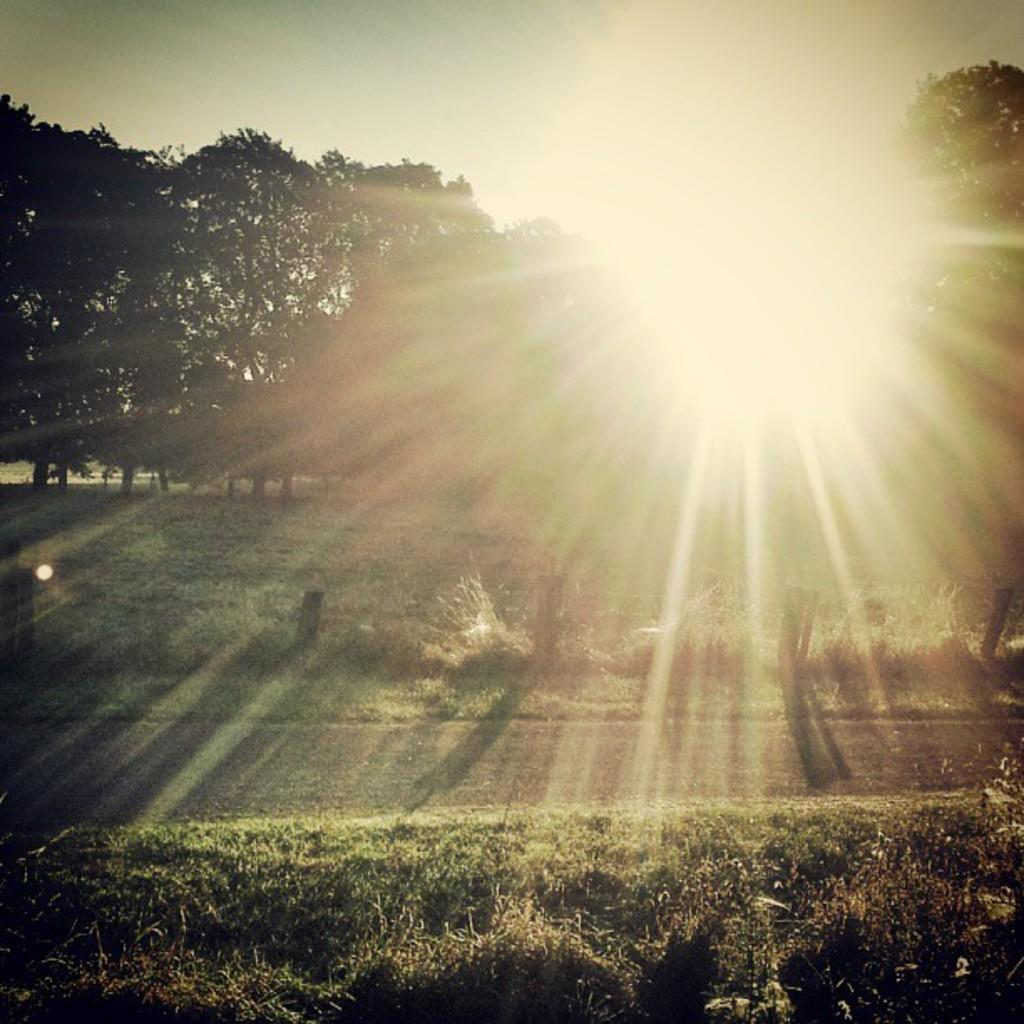What type of landscape is at the bottom side of the image? There is grassland at the bottom side of the image. What type of vegetation can be seen in the image? There are trees in the image. What celestial body is visible at the top side of the image? The sun is visible at the top side of the image. What type of meat is being cooked on the grill in the image? There is no grill or meat present in the image. How many eggs are visible in the image? There are no eggs present in the image. 